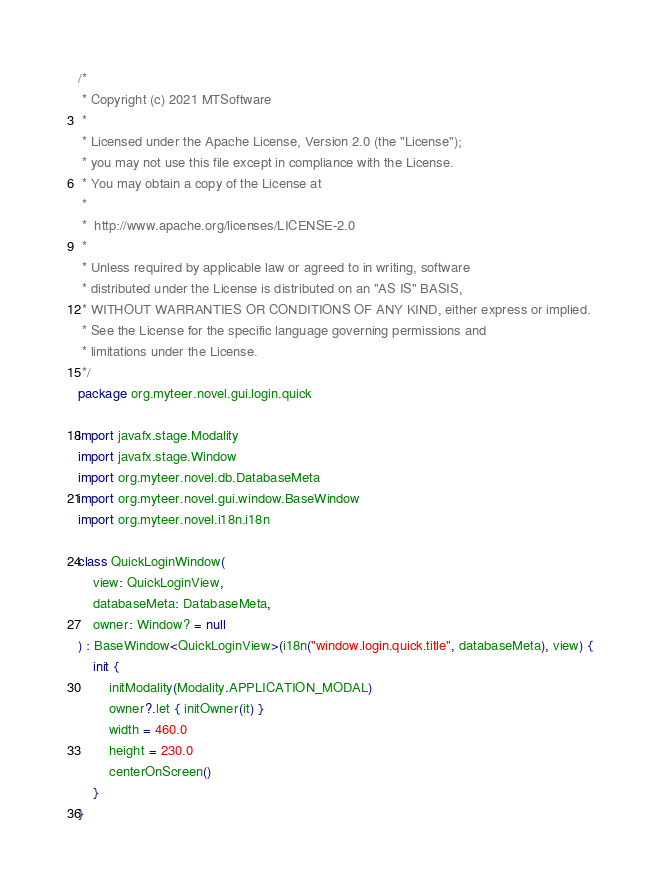Convert code to text. <code><loc_0><loc_0><loc_500><loc_500><_Kotlin_>/*
 * Copyright (c) 2021 MTSoftware
 *
 * Licensed under the Apache License, Version 2.0 (the "License");
 * you may not use this file except in compliance with the License.
 * You may obtain a copy of the License at
 *
 *  http://www.apache.org/licenses/LICENSE-2.0
 *
 * Unless required by applicable law or agreed to in writing, software
 * distributed under the License is distributed on an "AS IS" BASIS,
 * WITHOUT WARRANTIES OR CONDITIONS OF ANY KIND, either express or implied.
 * See the License for the specific language governing permissions and
 * limitations under the License.
 */
package org.myteer.novel.gui.login.quick

import javafx.stage.Modality
import javafx.stage.Window
import org.myteer.novel.db.DatabaseMeta
import org.myteer.novel.gui.window.BaseWindow
import org.myteer.novel.i18n.i18n

class QuickLoginWindow(
    view: QuickLoginView,
    databaseMeta: DatabaseMeta,
    owner: Window? = null
) : BaseWindow<QuickLoginView>(i18n("window.login.quick.title", databaseMeta), view) {
    init {
        initModality(Modality.APPLICATION_MODAL)
        owner?.let { initOwner(it) }
        width = 460.0
        height = 230.0
        centerOnScreen()
    }
}</code> 